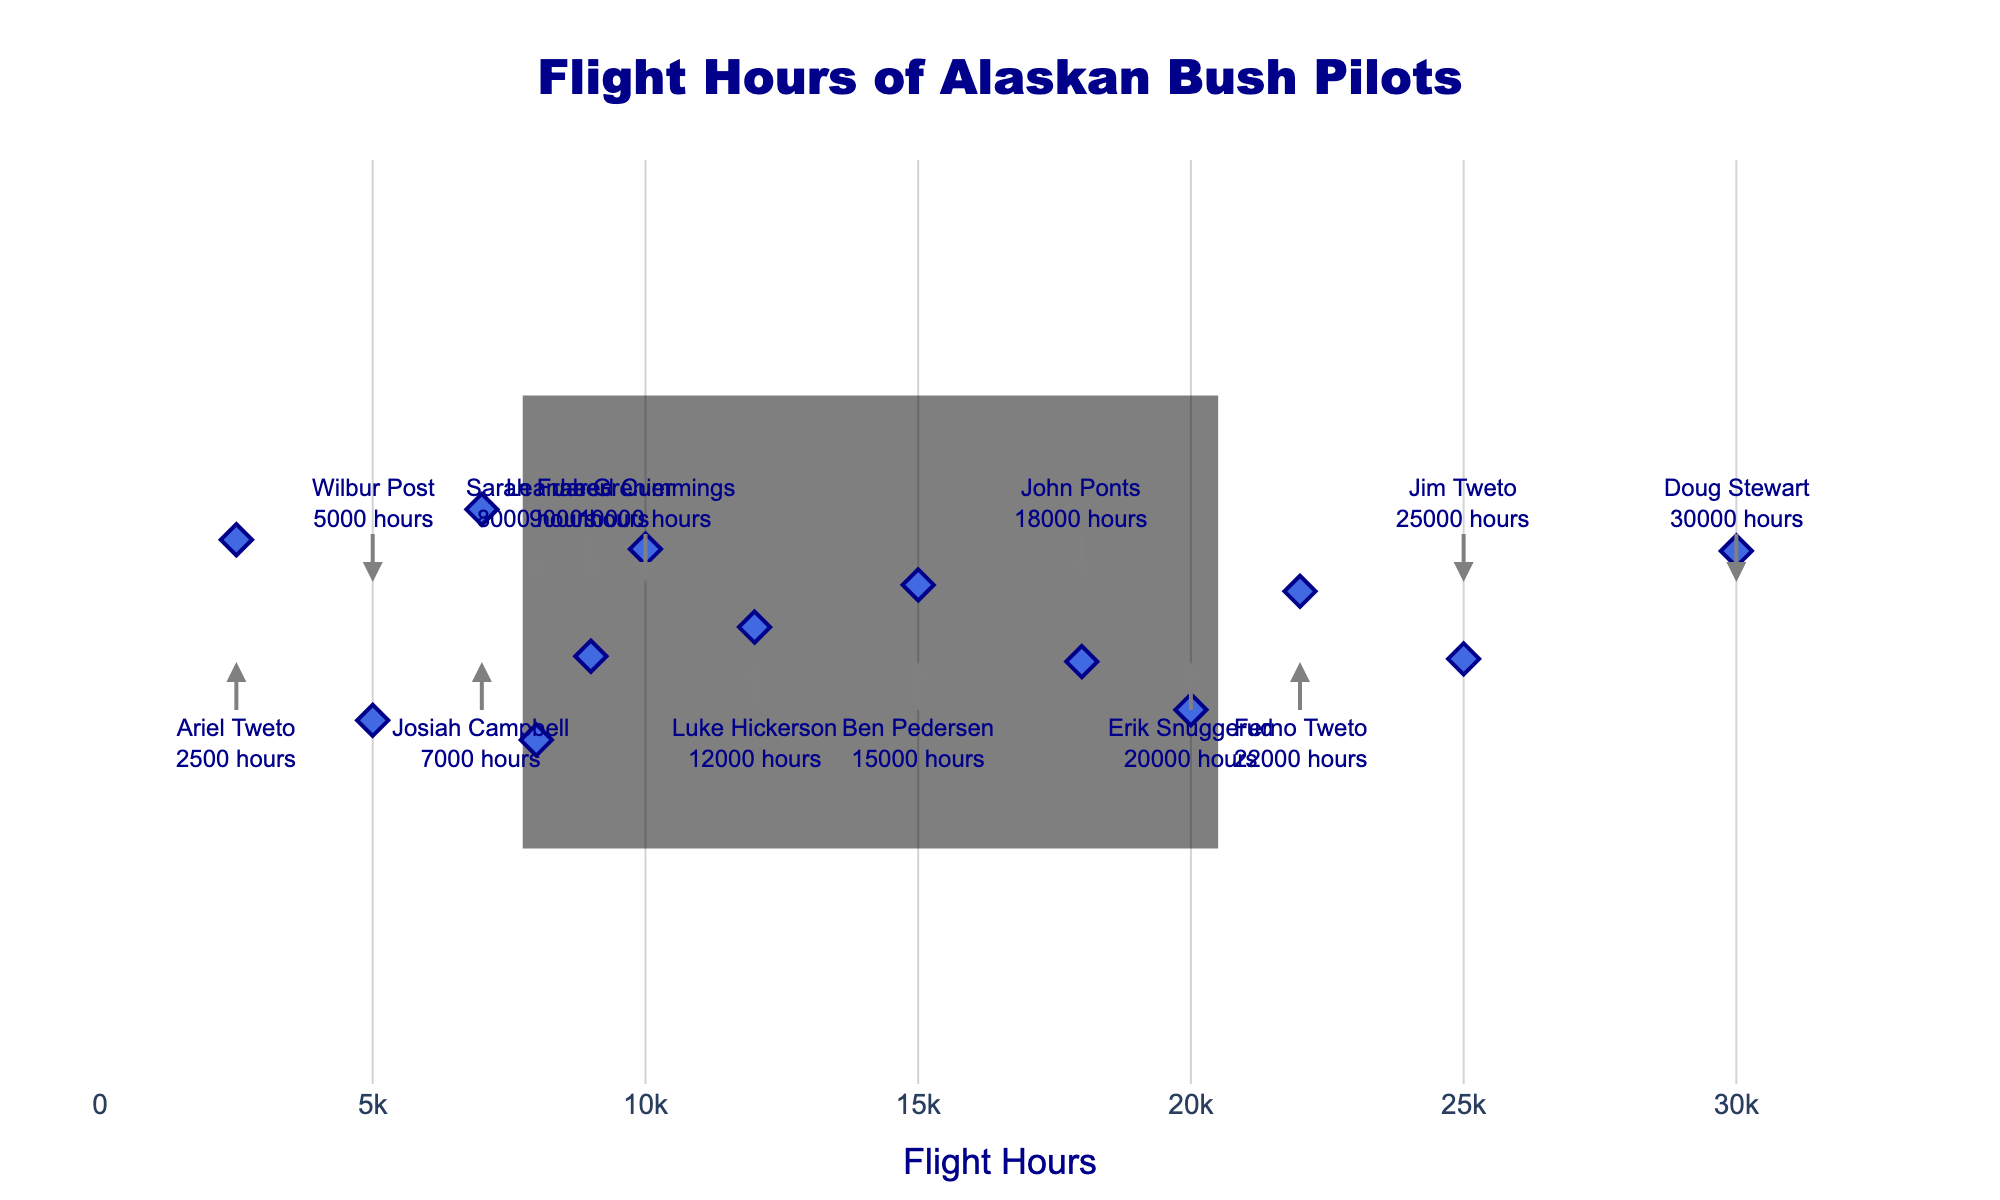What's the title of the figure? The title of the figure is placed at the top center of the plot, often in larger, bold font. Reading it directly, you can see it is designed to convey the main topic of the plot.
Answer: Flight Hours of Alaskan Bush Pilots How many pilots are shown in the plot? Each pilot is represented as a point on the strip plot. By counting the annotations, or the number of data points, you can determine how many pilots are visualized.
Answer: 13 Which pilot has the highest number of flight hours? The pilot with the highest flight hours corresponds to the point furthest to the right. The annotation near this point indicates the pilot's name and their flight hours.
Answer: Doug Stewart What is the flight hours range displayed in the plot? To determine the range, observe the minimum and maximum flight hours shown on the x-axis. The furthest left point indicates the minimum, while the furthest right point indicates the maximum.
Answer: 2,500 to 30,000 hours What’s the difference in flight hours between Jim Tweto and Ariel Tweto? Identify the flight hours for Jim Tweto (25,000 hours) and Ariel Tweto (2,500 hours). Subtract Ariel's flight hours from Jim’s.
Answer: 22,500 hours Which pilot has more flight hours, Ben Pedersen or Luke Hickerson? Compare the positions of the points for Ben Pedersen and Luke Hickerson on the x-axis. The further to the right indicates more flight hours.
Answer: Luke Hickerson What is the median flight hours among the pilots? Arrange the flight hours in ascending order and find the middle value. With 13 pilots, the median is the 7th value in the sorted list.
Answer: 12,000 hours (Luke Hickerson) How many pilots have over 20,000 flight hours? Count the number of points positioned to the right of the 20,000 hours mark on the x-axis.
Answer: 3 Which two pilots have the closest flight hours? Identify pairs of adjacent points and compare their flight hours. The pair with the smallest difference between their values has the closest flight hours.
Answer: Ferno Tweto and Erik Snuggerud How much more flight experience does Doug Stewart have compared to Wilbur Post? Subtract Wilbur Post's flight hours (5,000) from Doug Stewart's flight hours (30,000).
Answer: 25,000 hours 